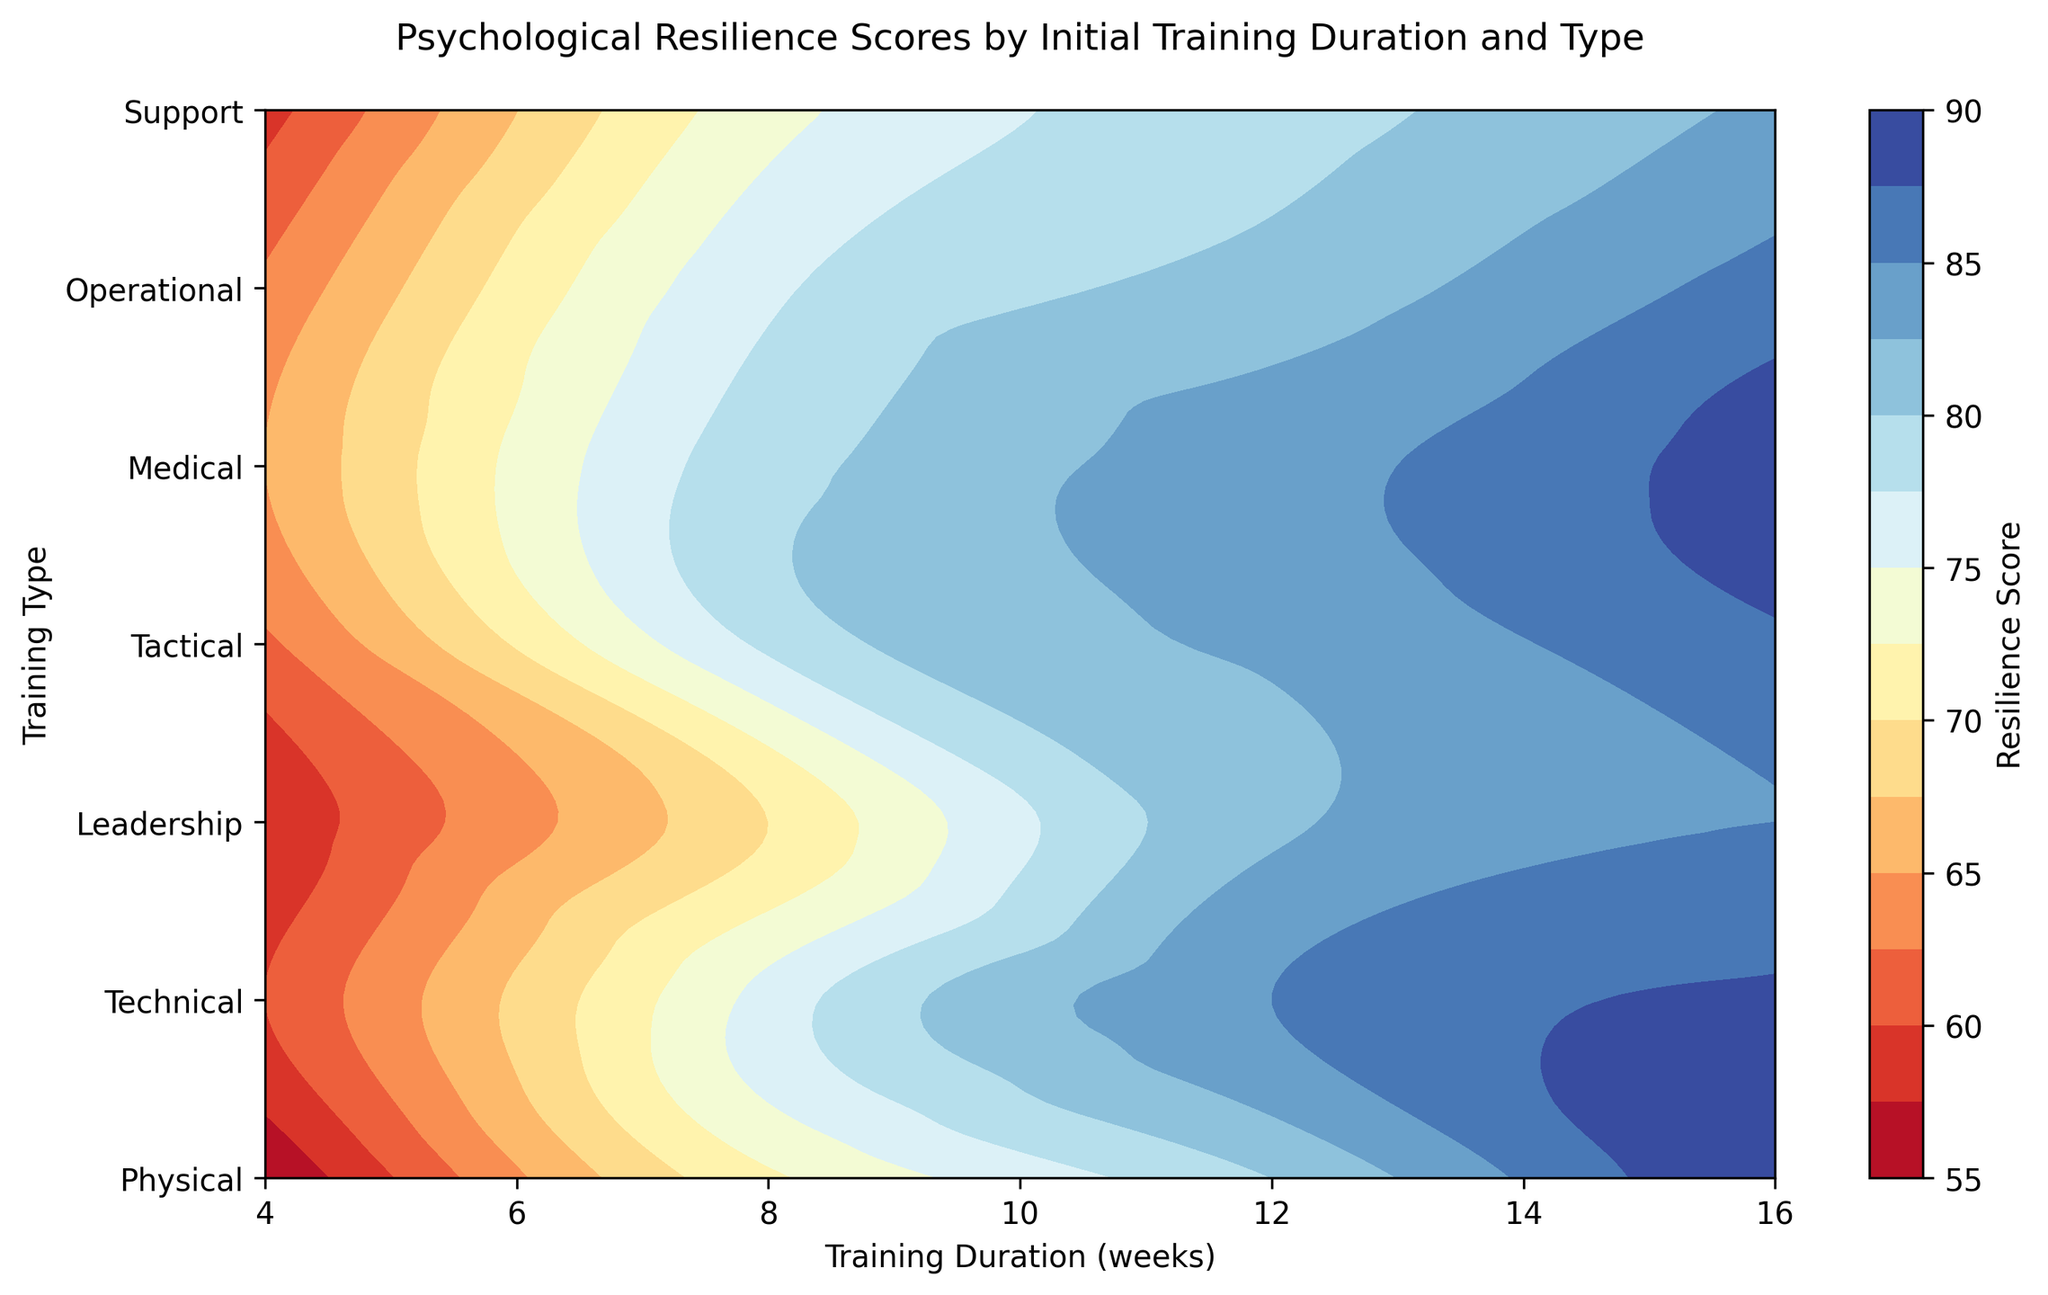What training type results in the highest resilience score for a 12-week training duration? To answer this, locate the 12-week mark on the x-axis, then observe the highest y-axis point, determining the training type associated with the highest visual score color. The contour lines and color gradients can help indicate the highest score visually.
Answer: Technical Which training type has the lowest resilience score for a 4-week training duration? Identify the 4-week mark on the x-axis, then find the lowest point on the y-axis that corresponds to the darkest or least intensified contour, indicating the lowest resilience score.
Answer: Physical By how much does the resilience score increase on average per additional 4 weeks of training in the Physical training type? Examine the contour intervals for the Physical training type at 4, 8, 12, and 16 weeks. Note the resilience scores (55, 72, 80, 90), then calculate the differences (72-55, 80-72, 90-80) and average the three differences.
Answer: 12 Which training type shows the least difference in resilience scores between 8 and 12 weeks? Compare the change in color intensity or contour spacing between 8 and 12 weeks for each training type. Determine which type has the smallest change in resilience score, indicated by the least difference in visual intensity.
Answer: Support What is the approximate resilience score for Technical training at 10 weeks? Visual interpolation is done by finding the 10-week mark on the x-axis and locating the corresponding point on the Technical contour line, then estimating the score based on surrounding contour lines or color gradient.
Answer: 81 